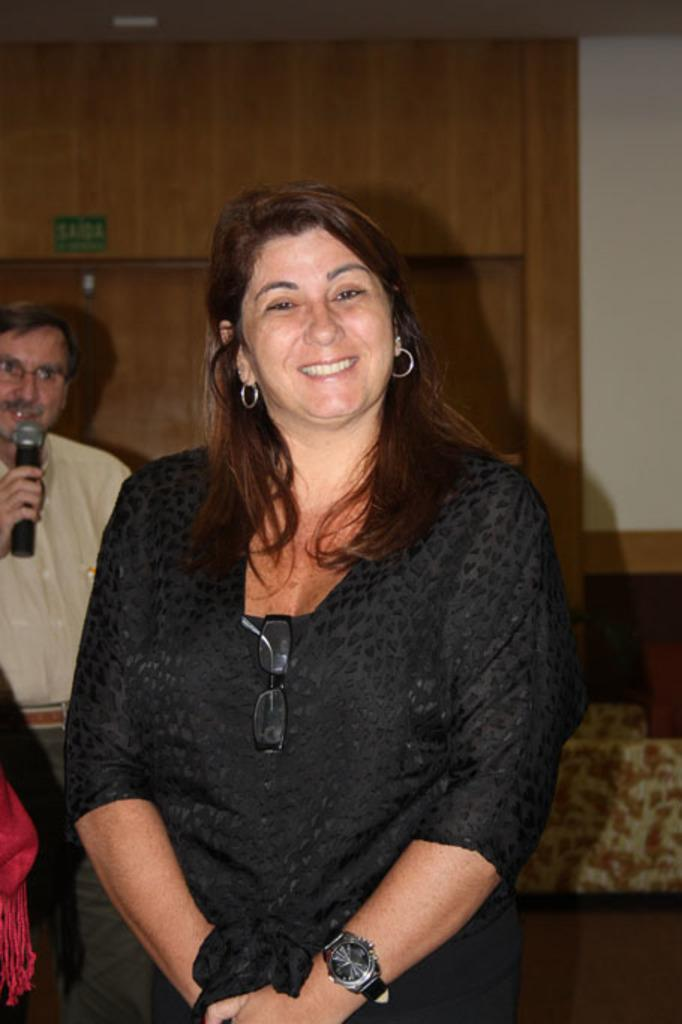How many people are in the image? There are persons in the image. What is the person in the background holding? The person in the background is holding a mic. What can be seen in the background of the image? There is a wall visible in the background. What type of knot is being tied by the judge in the image? There is no judge or knot present in the image. What angle is the person holding the mic positioned at in the image? The angle at which the person holding the mic is positioned cannot be determined from the image alone. 